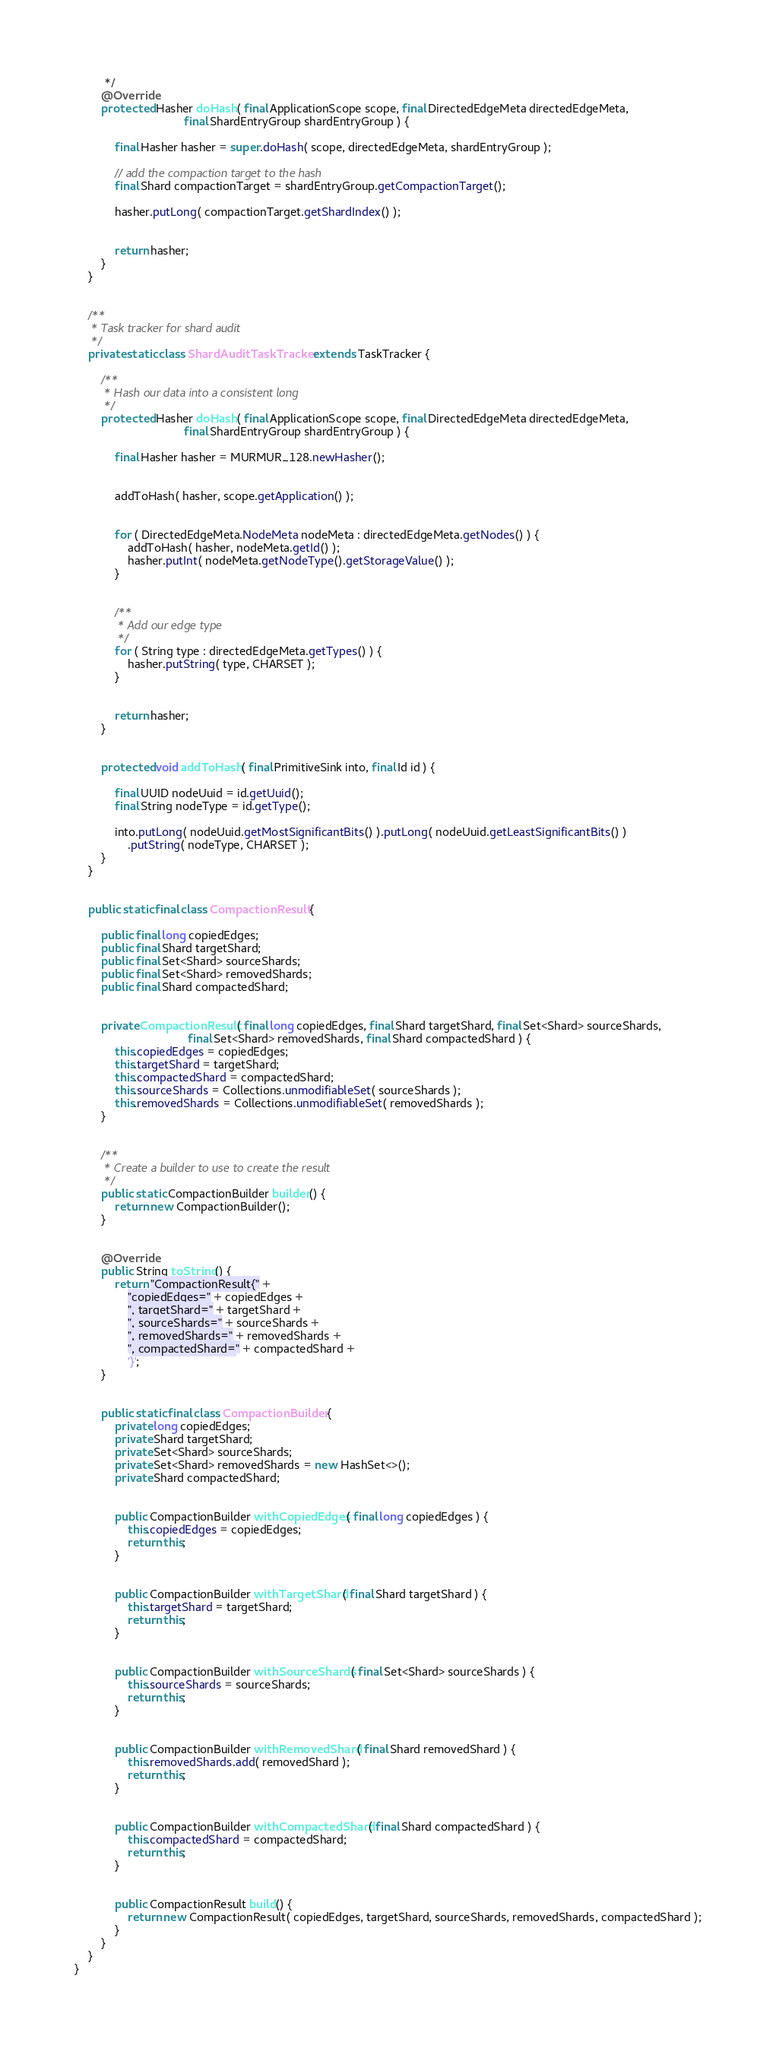<code> <loc_0><loc_0><loc_500><loc_500><_Java_>         */
        @Override
        protected Hasher doHash( final ApplicationScope scope, final DirectedEdgeMeta directedEdgeMeta,
                                 final ShardEntryGroup shardEntryGroup ) {

            final Hasher hasher = super.doHash( scope, directedEdgeMeta, shardEntryGroup );

            // add the compaction target to the hash
            final Shard compactionTarget = shardEntryGroup.getCompactionTarget();

            hasher.putLong( compactionTarget.getShardIndex() );


            return hasher;
        }
    }


    /**
     * Task tracker for shard audit
     */
    private static class ShardAuditTaskTracker extends TaskTracker {

        /**
         * Hash our data into a consistent long
         */
        protected Hasher doHash( final ApplicationScope scope, final DirectedEdgeMeta directedEdgeMeta,
                                 final ShardEntryGroup shardEntryGroup ) {

            final Hasher hasher = MURMUR_128.newHasher();


            addToHash( hasher, scope.getApplication() );


            for ( DirectedEdgeMeta.NodeMeta nodeMeta : directedEdgeMeta.getNodes() ) {
                addToHash( hasher, nodeMeta.getId() );
                hasher.putInt( nodeMeta.getNodeType().getStorageValue() );
            }


            /**
             * Add our edge type
             */
            for ( String type : directedEdgeMeta.getTypes() ) {
                hasher.putString( type, CHARSET );
            }


            return hasher;
        }


        protected void addToHash( final PrimitiveSink into, final Id id ) {

            final UUID nodeUuid = id.getUuid();
            final String nodeType = id.getType();

            into.putLong( nodeUuid.getMostSignificantBits() ).putLong( nodeUuid.getLeastSignificantBits() )
                .putString( nodeType, CHARSET );
        }
    }


    public static final class CompactionResult {

        public final long copiedEdges;
        public final Shard targetShard;
        public final Set<Shard> sourceShards;
        public final Set<Shard> removedShards;
        public final Shard compactedShard;


        private CompactionResult( final long copiedEdges, final Shard targetShard, final Set<Shard> sourceShards,
                                  final Set<Shard> removedShards, final Shard compactedShard ) {
            this.copiedEdges = copiedEdges;
            this.targetShard = targetShard;
            this.compactedShard = compactedShard;
            this.sourceShards = Collections.unmodifiableSet( sourceShards );
            this.removedShards = Collections.unmodifiableSet( removedShards );
        }


        /**
         * Create a builder to use to create the result
         */
        public static CompactionBuilder builder() {
            return new CompactionBuilder();
        }


        @Override
        public String toString() {
            return "CompactionResult{" +
                "copiedEdges=" + copiedEdges +
                ", targetShard=" + targetShard +
                ", sourceShards=" + sourceShards +
                ", removedShards=" + removedShards +
                ", compactedShard=" + compactedShard +
                '}';
        }


        public static final class CompactionBuilder {
            private long copiedEdges;
            private Shard targetShard;
            private Set<Shard> sourceShards;
            private Set<Shard> removedShards = new HashSet<>();
            private Shard compactedShard;


            public CompactionBuilder withCopiedEdges( final long copiedEdges ) {
                this.copiedEdges = copiedEdges;
                return this;
            }


            public CompactionBuilder withTargetShard( final Shard targetShard ) {
                this.targetShard = targetShard;
                return this;
            }


            public CompactionBuilder withSourceShards( final Set<Shard> sourceShards ) {
                this.sourceShards = sourceShards;
                return this;
            }


            public CompactionBuilder withRemovedShard( final Shard removedShard ) {
                this.removedShards.add( removedShard );
                return this;
            }


            public CompactionBuilder withCompactedShard( final Shard compactedShard ) {
                this.compactedShard = compactedShard;
                return this;
            }


            public CompactionResult build() {
                return new CompactionResult( copiedEdges, targetShard, sourceShards, removedShards, compactedShard );
            }
        }
    }
}
</code> 